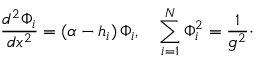Convert formula to latex. <formula><loc_0><loc_0><loc_500><loc_500>{ \frac { d ^ { 2 } \Phi _ { i } } { d x ^ { 2 } } } = ( \alpha - h _ { i } ) \, \Phi _ { i } , \quad \sum _ { i = 1 } ^ { N } \Phi _ { i } ^ { 2 } = { \frac { 1 } { g ^ { 2 } } } \cdot</formula> 